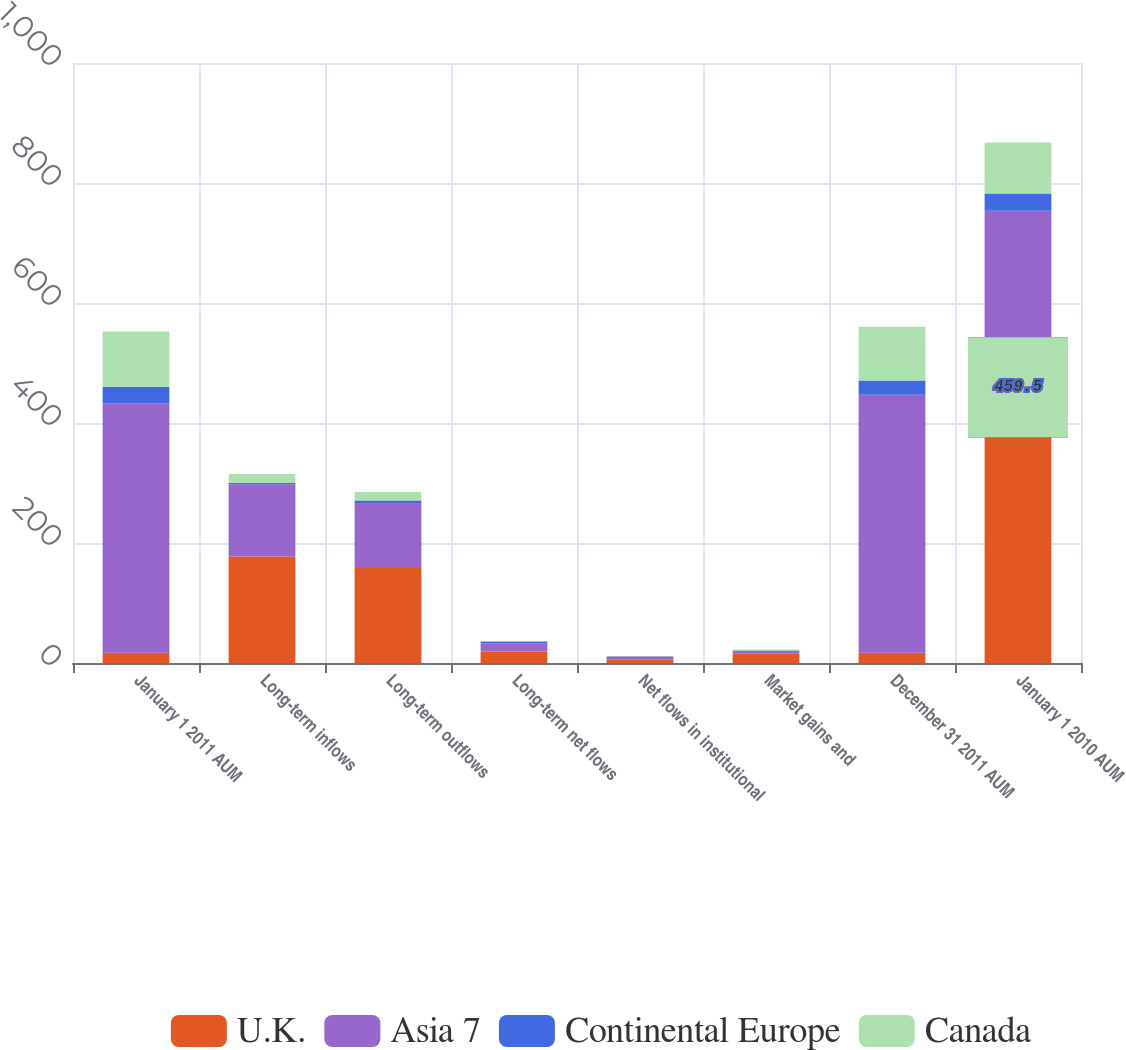Convert chart. <chart><loc_0><loc_0><loc_500><loc_500><stacked_bar_chart><ecel><fcel>January 1 2011 AUM<fcel>Long-term inflows<fcel>Long-term outflows<fcel>Long-term net flows<fcel>Net flows in institutional<fcel>Market gains and<fcel>December 31 2011 AUM<fcel>January 1 2010 AUM<nl><fcel>U.K.<fcel>17.25<fcel>177.6<fcel>158.4<fcel>19.2<fcel>5.3<fcel>15.3<fcel>17.25<fcel>459.5<nl><fcel>Asia 7<fcel>415.4<fcel>120.4<fcel>106.9<fcel>13.5<fcel>5.7<fcel>4.6<fcel>430<fcel>294.1<nl><fcel>Continental Europe<fcel>27.9<fcel>2.6<fcel>5.7<fcel>3.1<fcel>0.1<fcel>0.8<fcel>23.4<fcel>29<nl><fcel>Canada<fcel>92.1<fcel>14.3<fcel>13.8<fcel>0.5<fcel>0.7<fcel>1.6<fcel>89.8<fcel>84.9<nl></chart> 